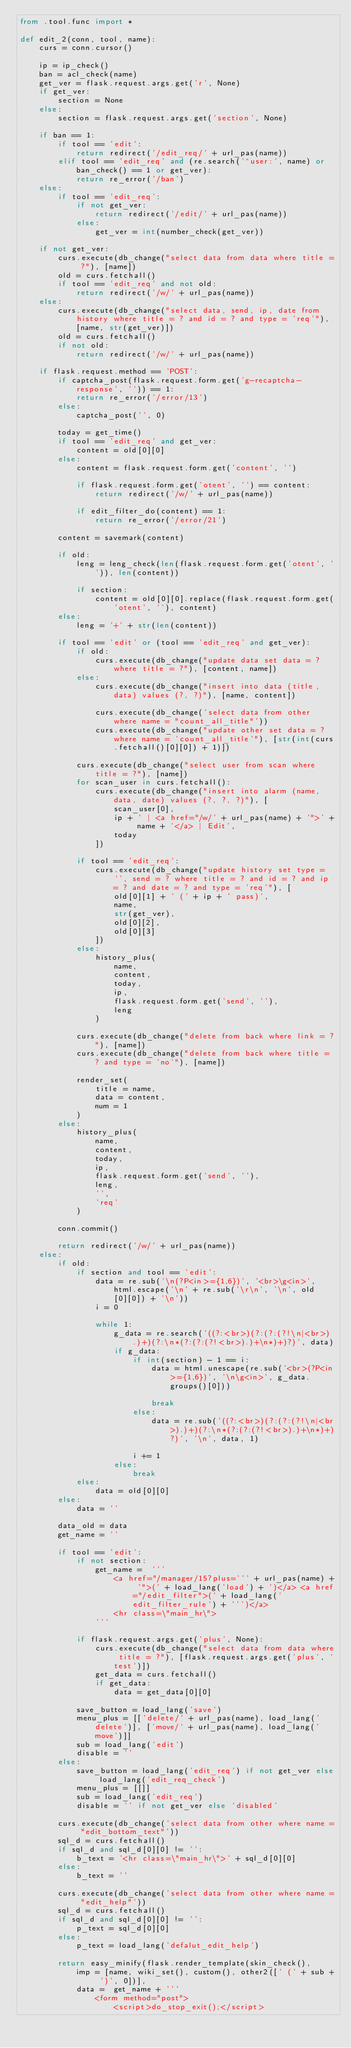<code> <loc_0><loc_0><loc_500><loc_500><_Python_>from .tool.func import *

def edit_2(conn, tool, name):
    curs = conn.cursor()

    ip = ip_check()
    ban = acl_check(name)
    get_ver = flask.request.args.get('r', None)
    if get_ver:
        section = None
    else:
        section = flask.request.args.get('section', None)

    if ban == 1:
        if tool == 'edit':
            return redirect('/edit_req/' + url_pas(name))
        elif tool == 'edit_req' and (re.search('^user:', name) or ban_check() == 1 or get_ver):
            return re_error('/ban')
    else:
        if tool == 'edit_req':
            if not get_ver:
                return redirect('/edit/' + url_pas(name))
            else:
                get_ver = int(number_check(get_ver))
        
    if not get_ver:
        curs.execute(db_change("select data from data where title = ?"), [name])
        old = curs.fetchall()
        if tool == 'edit_req' and not old:
            return redirect('/w/' + url_pas(name))
    else:
        curs.execute(db_change("select data, send, ip, date from history where title = ? and id = ? and type = 'req'"), [name, str(get_ver)])
        old = curs.fetchall()
        if not old:
            return redirect('/w/' + url_pas(name))
    
    if flask.request.method == 'POST':
        if captcha_post(flask.request.form.get('g-recaptcha-response', '')) == 1:
            return re_error('/error/13')
        else:
            captcha_post('', 0)

        today = get_time()
        if tool == 'edit_req' and get_ver:
            content = old[0][0]
        else:
            content = flask.request.form.get('content', '')

            if flask.request.form.get('otent', '') == content:
                return redirect('/w/' + url_pas(name))
            
            if edit_filter_do(content) == 1:
                return re_error('/error/21')

        content = savemark(content)
        
        if old:
            leng = leng_check(len(flask.request.form.get('otent', '')), len(content))
            
            if section:
                content = old[0][0].replace(flask.request.form.get('otent', ''), content)
        else:
            leng = '+' + str(len(content))

        if tool == 'edit' or (tool == 'edit_req' and get_ver):
            if old:
                curs.execute(db_change("update data set data = ? where title = ?"), [content, name])
            else:
                curs.execute(db_change("insert into data (title, data) values (?, ?)"), [name, content])

                curs.execute(db_change('select data from other where name = "count_all_title"'))
                curs.execute(db_change("update other set data = ? where name = 'count_all_title'"), [str(int(curs.fetchall()[0][0]) + 1)])

            curs.execute(db_change("select user from scan where title = ?"), [name])
            for scan_user in curs.fetchall():
                curs.execute(db_change("insert into alarm (name, data, date) values (?, ?, ?)"), [
                    scan_user[0],
                    ip + ' | <a href="/w/' + url_pas(name) + '">' + name + '</a> | Edit', 
                    today
                ])

            if tool == 'edit_req':
                curs.execute(db_change("update history set type = '', send = ? where title = ? and id = ? and ip = ? and date = ? and type = 'req'"), [
                    old[0][1] + ' (' + ip + ' pass)', 
                    name,
                    str(get_ver),
                    old[0][2],
                    old[0][3]
                ])
            else:
                history_plus(
                    name,
                    content,
                    today,
                    ip,
                    flask.request.form.get('send', ''),
                    leng
                )
            
            curs.execute(db_change("delete from back where link = ?"), [name])
            curs.execute(db_change("delete from back where title = ? and type = 'no'"), [name])
            
            render_set(
                title = name,
                data = content,
                num = 1
            )
        else:
            history_plus(
                name,
                content,
                today,
                ip,
                flask.request.form.get('send', ''),
                leng,
                '',
                'req'
            )
        
        conn.commit()
        
        return redirect('/w/' + url_pas(name))
    else:            
        if old:
            if section and tool == 'edit':
                data = re.sub('\n(?P<in>={1,6})', '<br>\g<in>', html.escape('\n' + re.sub('\r\n', '\n', old[0][0]) + '\n'))
                i = 0

                while 1:
                    g_data = re.search('((?:<br>)(?:(?:(?!\n|<br>).)+)(?:\n*(?:(?:(?!<br>).)+\n*)+)?)', data)
                    if g_data:
                        if int(section) - 1 == i:
                            data = html.unescape(re.sub('<br>(?P<in>={1,6})', '\n\g<in>', g_data.groups()[0]))
                            
                            break
                        else:
                            data = re.sub('((?:<br>)(?:(?:(?!\n|<br>).)+)(?:\n*(?:(?:(?!<br>).)+\n*)+)?)', '\n', data, 1)

                        i += 1
                    else:
                        break
            else:
                data = old[0][0]
        else:
            data = ''
            
        data_old = data
        get_name = ''

        if tool == 'edit':
            if not section:
                get_name =  '''
                    <a href="/manager/15?plus=''' + url_pas(name) + '">(' + load_lang('load') + ')</a> <a href="/edit_filter">(' + load_lang('edit_filter_rule') + ''')</a>
                    <hr class=\"main_hr\">
                '''
                
            if flask.request.args.get('plus', None):
                curs.execute(db_change("select data from data where title = ?"), [flask.request.args.get('plus', 'test')])
                get_data = curs.fetchall()
                if get_data:
                    data = get_data[0][0]

            save_button = load_lang('save')
            menu_plus = [['delete/' + url_pas(name), load_lang('delete')], ['move/' + url_pas(name), load_lang('move')]]
            sub = load_lang('edit')
            disable = ''
        else:
            save_button = load_lang('edit_req') if not get_ver else load_lang('edit_req_check') 
            menu_plus = [[]]
            sub = load_lang('edit_req')
            disable = '' if not get_ver else 'disabled'

        curs.execute(db_change('select data from other where name = "edit_bottom_text"'))
        sql_d = curs.fetchall()
        if sql_d and sql_d[0][0] != '':
            b_text = '<hr class=\"main_hr\">' + sql_d[0][0]
        else:
            b_text = ''

        curs.execute(db_change('select data from other where name = "edit_help"'))
        sql_d = curs.fetchall()
        if sql_d and sql_d[0][0] != '':
            p_text = sql_d[0][0]
        else:
            p_text = load_lang('defalut_edit_help')

        return easy_minify(flask.render_template(skin_check(), 
            imp = [name, wiki_set(), custom(), other2([' (' + sub + ')', 0])],
            data =  get_name + '''
                <form method="post">
                    <script>do_stop_exit();</script></code> 